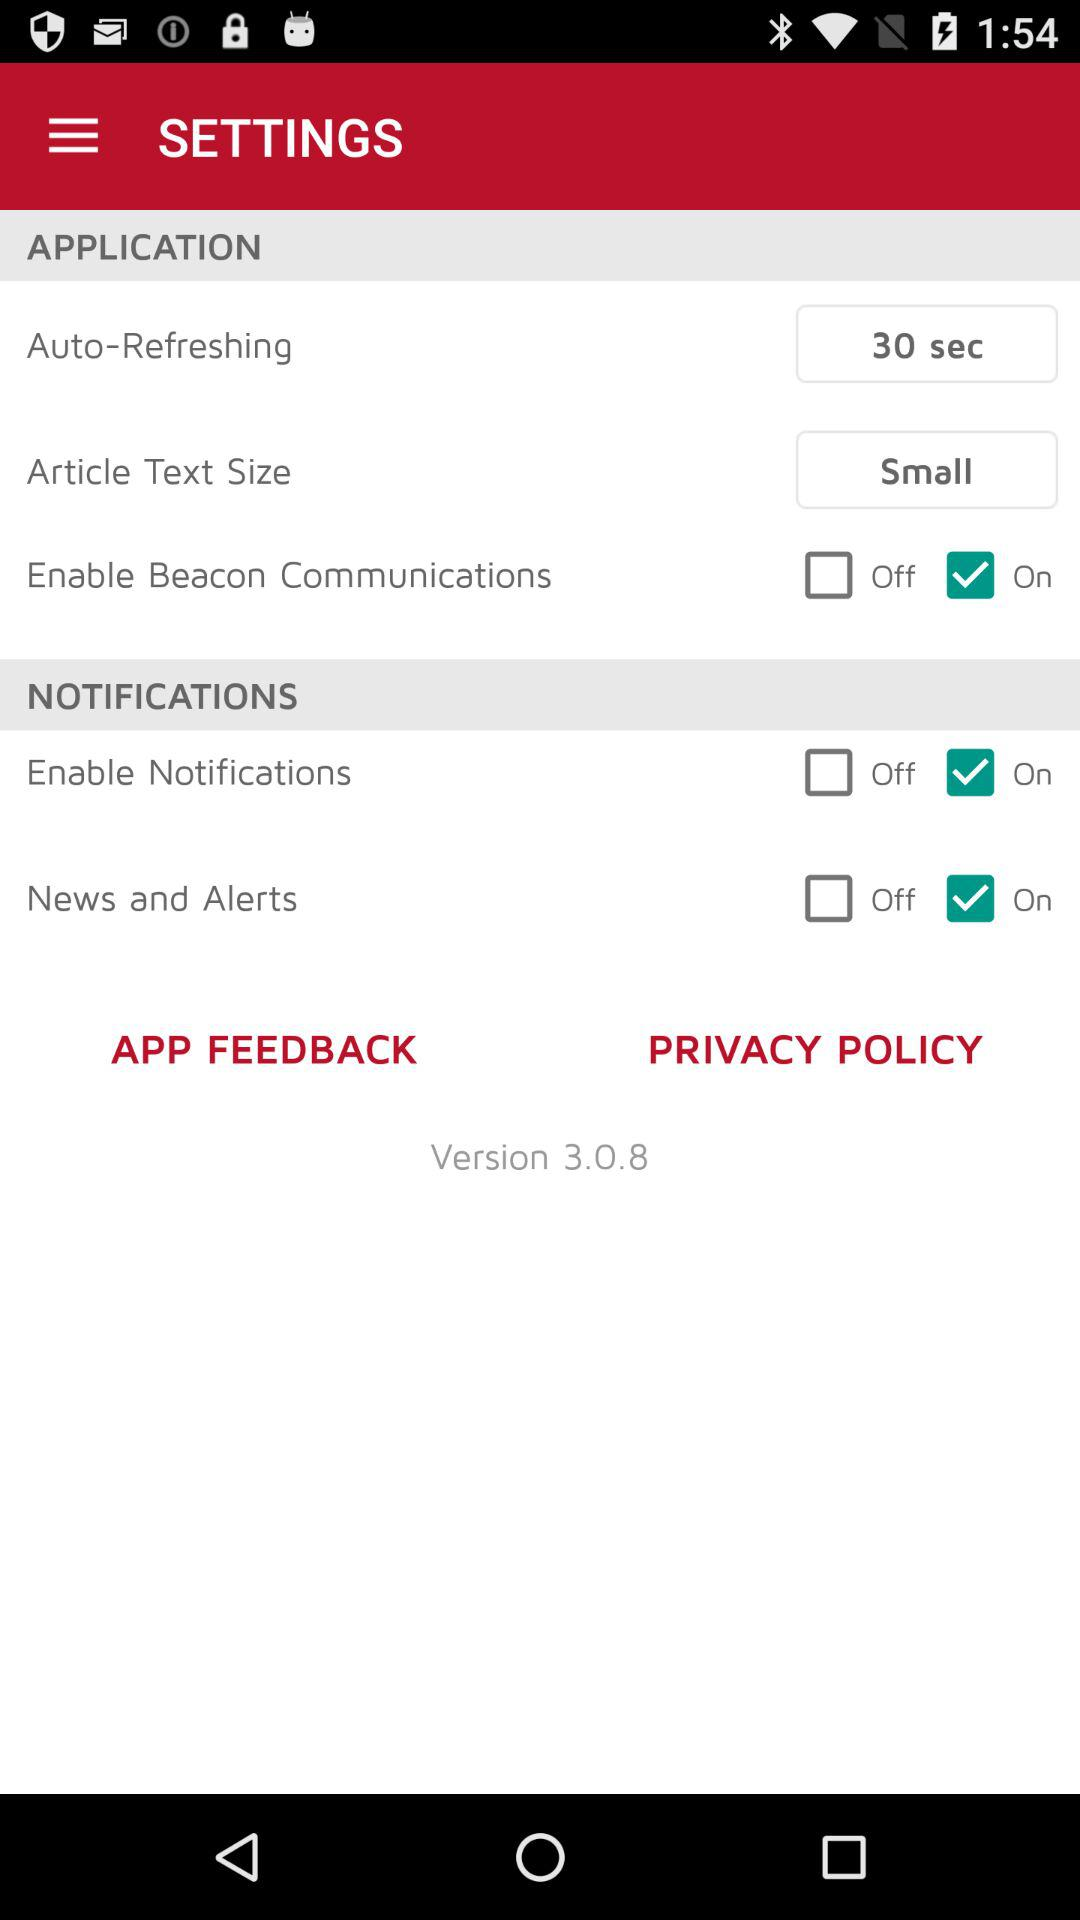Which article text size is selected? The selected article text size is "Small". 